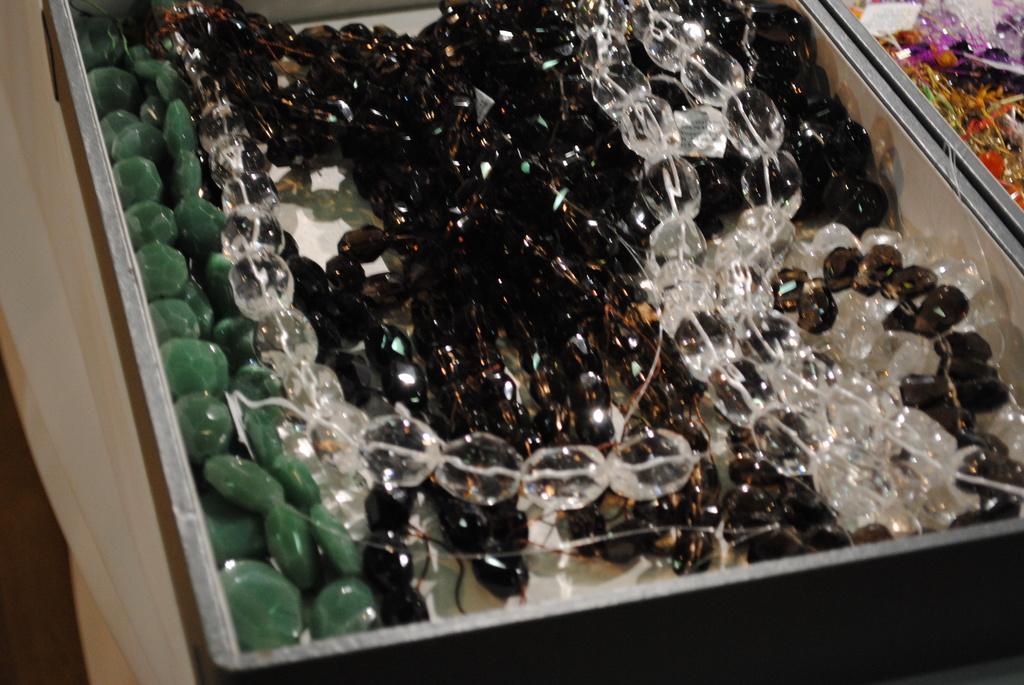Could you give a brief overview of what you see in this image? In this picture, we see a marble pearls in green, white and black color are placed in the box. Beside the box, we see a wall in white color. 